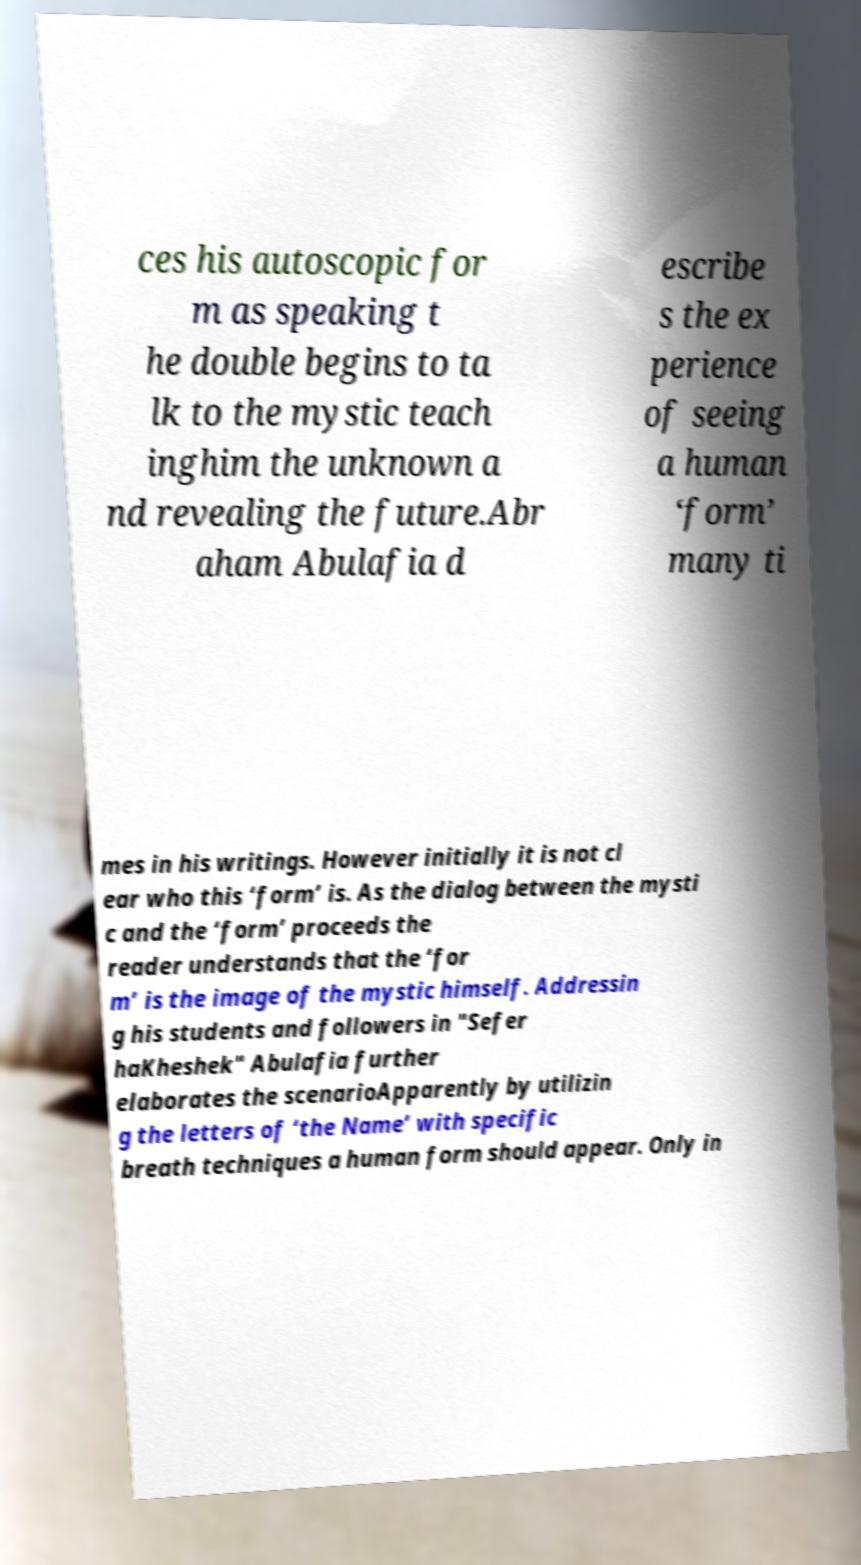Can you read and provide the text displayed in the image?This photo seems to have some interesting text. Can you extract and type it out for me? ces his autoscopic for m as speaking t he double begins to ta lk to the mystic teach inghim the unknown a nd revealing the future.Abr aham Abulafia d escribe s the ex perience of seeing a human ‘form’ many ti mes in his writings. However initially it is not cl ear who this ‘form’ is. As the dialog between the mysti c and the ‘form’ proceeds the reader understands that the ‘for m’ is the image of the mystic himself. Addressin g his students and followers in "Sefer haKheshek" Abulafia further elaborates the scenarioApparently by utilizin g the letters of ‘the Name’ with specific breath techniques a human form should appear. Only in 